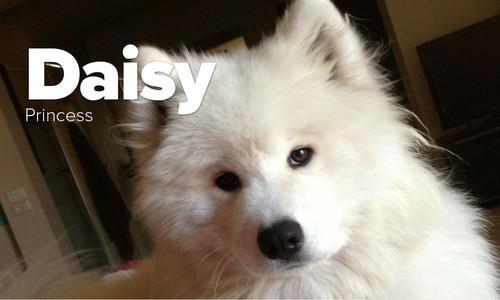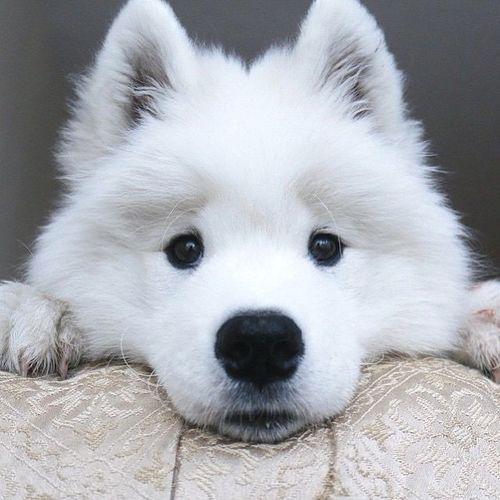The first image is the image on the left, the second image is the image on the right. For the images shown, is this caption "There are at most 2 dogs in the image pair" true? Answer yes or no. Yes. The first image is the image on the left, the second image is the image on the right. Examine the images to the left and right. Is the description "There are at most two dogs." accurate? Answer yes or no. Yes. 